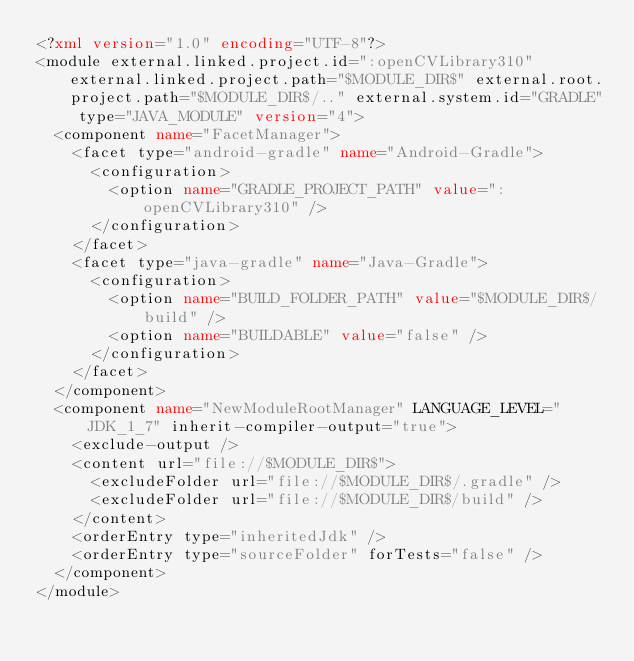Convert code to text. <code><loc_0><loc_0><loc_500><loc_500><_XML_><?xml version="1.0" encoding="UTF-8"?>
<module external.linked.project.id=":openCVLibrary310" external.linked.project.path="$MODULE_DIR$" external.root.project.path="$MODULE_DIR$/.." external.system.id="GRADLE" type="JAVA_MODULE" version="4">
  <component name="FacetManager">
    <facet type="android-gradle" name="Android-Gradle">
      <configuration>
        <option name="GRADLE_PROJECT_PATH" value=":openCVLibrary310" />
      </configuration>
    </facet>
    <facet type="java-gradle" name="Java-Gradle">
      <configuration>
        <option name="BUILD_FOLDER_PATH" value="$MODULE_DIR$/build" />
        <option name="BUILDABLE" value="false" />
      </configuration>
    </facet>
  </component>
  <component name="NewModuleRootManager" LANGUAGE_LEVEL="JDK_1_7" inherit-compiler-output="true">
    <exclude-output />
    <content url="file://$MODULE_DIR$">
      <excludeFolder url="file://$MODULE_DIR$/.gradle" />
      <excludeFolder url="file://$MODULE_DIR$/build" />
    </content>
    <orderEntry type="inheritedJdk" />
    <orderEntry type="sourceFolder" forTests="false" />
  </component>
</module></code> 